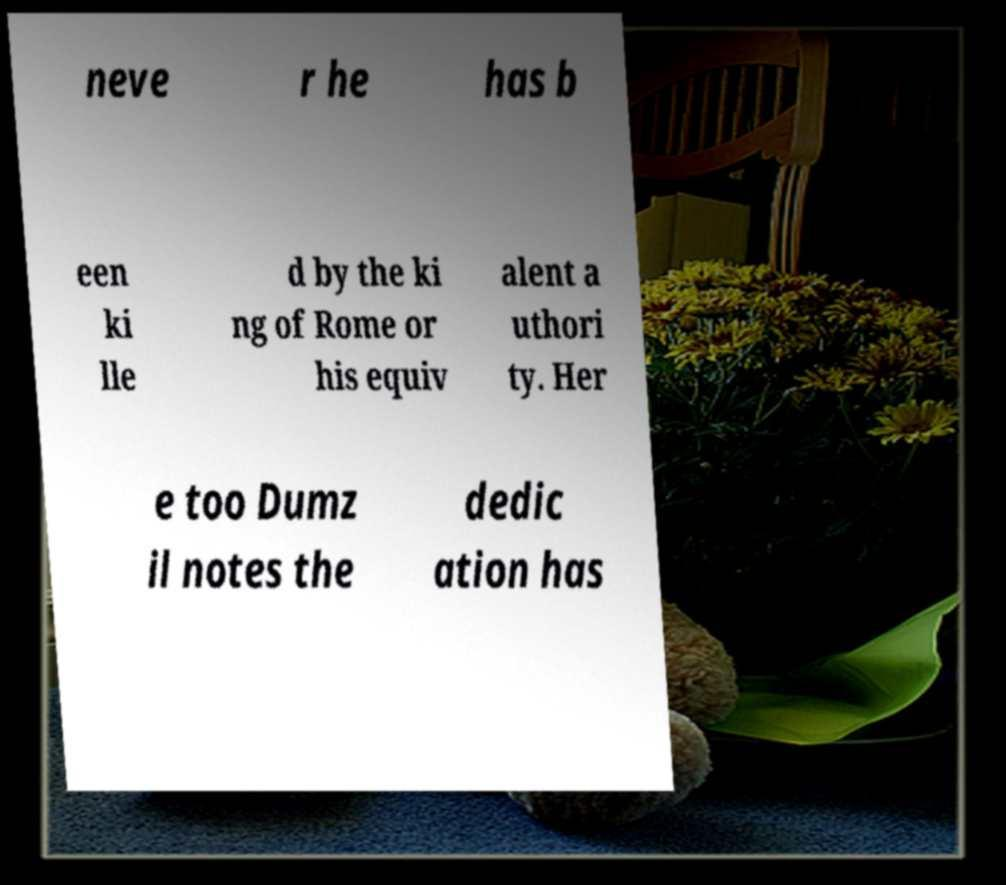What messages or text are displayed in this image? I need them in a readable, typed format. neve r he has b een ki lle d by the ki ng of Rome or his equiv alent a uthori ty. Her e too Dumz il notes the dedic ation has 